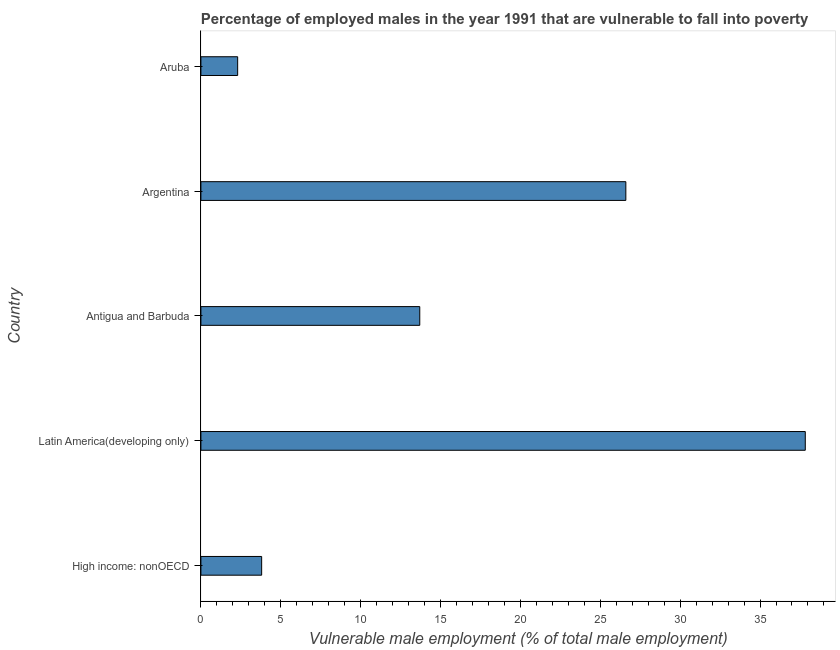Does the graph contain any zero values?
Give a very brief answer. No. Does the graph contain grids?
Give a very brief answer. No. What is the title of the graph?
Offer a very short reply. Percentage of employed males in the year 1991 that are vulnerable to fall into poverty. What is the label or title of the X-axis?
Your answer should be compact. Vulnerable male employment (% of total male employment). What is the percentage of employed males who are vulnerable to fall into poverty in Latin America(developing only)?
Your response must be concise. 37.83. Across all countries, what is the maximum percentage of employed males who are vulnerable to fall into poverty?
Your answer should be compact. 37.83. Across all countries, what is the minimum percentage of employed males who are vulnerable to fall into poverty?
Ensure brevity in your answer.  2.3. In which country was the percentage of employed males who are vulnerable to fall into poverty maximum?
Provide a succinct answer. Latin America(developing only). In which country was the percentage of employed males who are vulnerable to fall into poverty minimum?
Give a very brief answer. Aruba. What is the sum of the percentage of employed males who are vulnerable to fall into poverty?
Offer a very short reply. 84.23. What is the average percentage of employed males who are vulnerable to fall into poverty per country?
Make the answer very short. 16.85. What is the median percentage of employed males who are vulnerable to fall into poverty?
Keep it short and to the point. 13.7. What is the ratio of the percentage of employed males who are vulnerable to fall into poverty in Argentina to that in Latin America(developing only)?
Give a very brief answer. 0.7. Is the difference between the percentage of employed males who are vulnerable to fall into poverty in Argentina and Latin America(developing only) greater than the difference between any two countries?
Your answer should be compact. No. What is the difference between the highest and the second highest percentage of employed males who are vulnerable to fall into poverty?
Ensure brevity in your answer.  11.23. What is the difference between the highest and the lowest percentage of employed males who are vulnerable to fall into poverty?
Offer a terse response. 35.53. In how many countries, is the percentage of employed males who are vulnerable to fall into poverty greater than the average percentage of employed males who are vulnerable to fall into poverty taken over all countries?
Make the answer very short. 2. Are all the bars in the graph horizontal?
Make the answer very short. Yes. How many countries are there in the graph?
Your response must be concise. 5. What is the difference between two consecutive major ticks on the X-axis?
Give a very brief answer. 5. What is the Vulnerable male employment (% of total male employment) in High income: nonOECD?
Offer a very short reply. 3.8. What is the Vulnerable male employment (% of total male employment) in Latin America(developing only)?
Provide a short and direct response. 37.83. What is the Vulnerable male employment (% of total male employment) in Antigua and Barbuda?
Offer a terse response. 13.7. What is the Vulnerable male employment (% of total male employment) of Argentina?
Ensure brevity in your answer.  26.6. What is the Vulnerable male employment (% of total male employment) in Aruba?
Your answer should be very brief. 2.3. What is the difference between the Vulnerable male employment (% of total male employment) in High income: nonOECD and Latin America(developing only)?
Offer a terse response. -34.03. What is the difference between the Vulnerable male employment (% of total male employment) in High income: nonOECD and Antigua and Barbuda?
Make the answer very short. -9.9. What is the difference between the Vulnerable male employment (% of total male employment) in High income: nonOECD and Argentina?
Keep it short and to the point. -22.8. What is the difference between the Vulnerable male employment (% of total male employment) in High income: nonOECD and Aruba?
Your response must be concise. 1.5. What is the difference between the Vulnerable male employment (% of total male employment) in Latin America(developing only) and Antigua and Barbuda?
Your answer should be compact. 24.13. What is the difference between the Vulnerable male employment (% of total male employment) in Latin America(developing only) and Argentina?
Your answer should be very brief. 11.23. What is the difference between the Vulnerable male employment (% of total male employment) in Latin America(developing only) and Aruba?
Make the answer very short. 35.53. What is the difference between the Vulnerable male employment (% of total male employment) in Antigua and Barbuda and Argentina?
Your response must be concise. -12.9. What is the difference between the Vulnerable male employment (% of total male employment) in Argentina and Aruba?
Offer a terse response. 24.3. What is the ratio of the Vulnerable male employment (% of total male employment) in High income: nonOECD to that in Latin America(developing only)?
Ensure brevity in your answer.  0.1. What is the ratio of the Vulnerable male employment (% of total male employment) in High income: nonOECD to that in Antigua and Barbuda?
Offer a terse response. 0.28. What is the ratio of the Vulnerable male employment (% of total male employment) in High income: nonOECD to that in Argentina?
Keep it short and to the point. 0.14. What is the ratio of the Vulnerable male employment (% of total male employment) in High income: nonOECD to that in Aruba?
Offer a terse response. 1.65. What is the ratio of the Vulnerable male employment (% of total male employment) in Latin America(developing only) to that in Antigua and Barbuda?
Offer a terse response. 2.76. What is the ratio of the Vulnerable male employment (% of total male employment) in Latin America(developing only) to that in Argentina?
Provide a short and direct response. 1.42. What is the ratio of the Vulnerable male employment (% of total male employment) in Latin America(developing only) to that in Aruba?
Give a very brief answer. 16.45. What is the ratio of the Vulnerable male employment (% of total male employment) in Antigua and Barbuda to that in Argentina?
Provide a short and direct response. 0.52. What is the ratio of the Vulnerable male employment (% of total male employment) in Antigua and Barbuda to that in Aruba?
Give a very brief answer. 5.96. What is the ratio of the Vulnerable male employment (% of total male employment) in Argentina to that in Aruba?
Give a very brief answer. 11.56. 